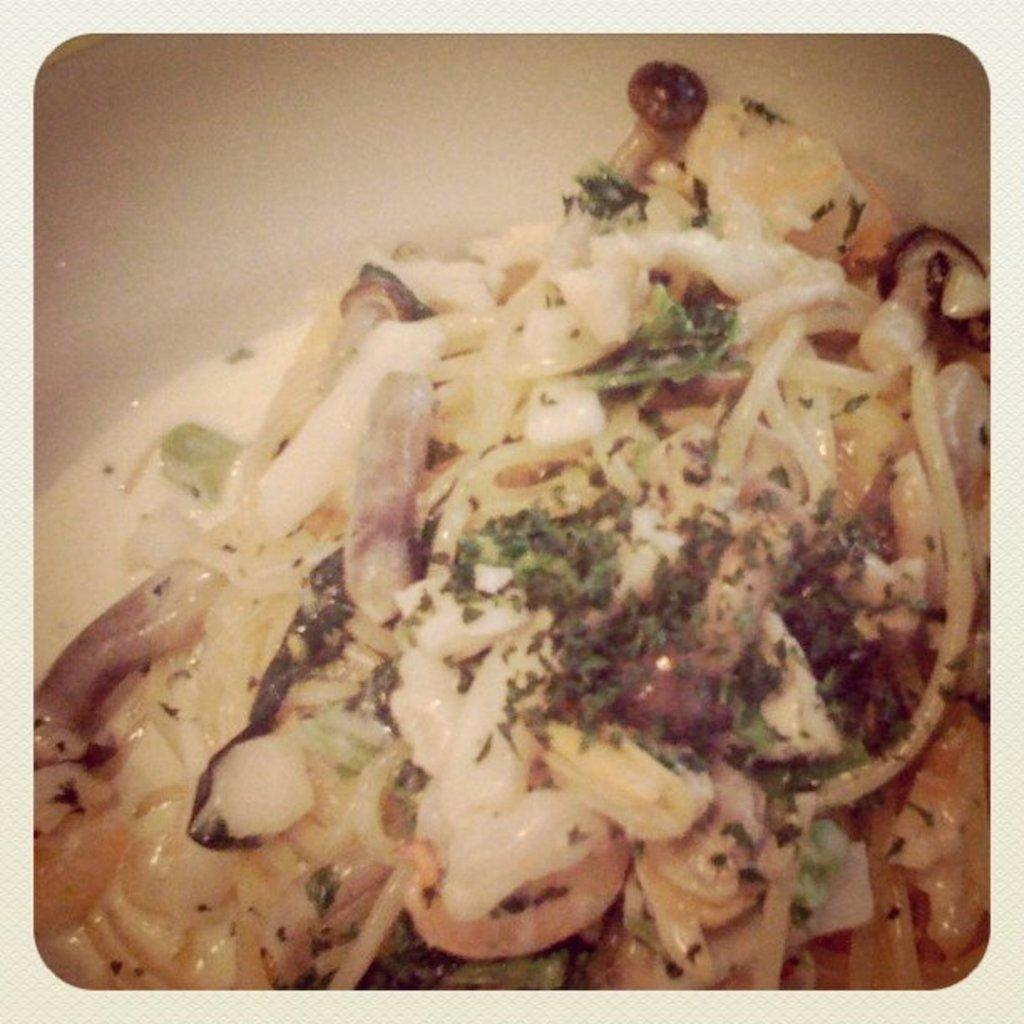What type of food is visible in the image? There is spaghetti in the image. What is sprinkled on top of the spaghetti? Coriander is sprinkled on top of the spaghetti. What is the cause of the argument between the light and care in the image? There is no argument, light, or care present in the image; it only features spaghetti with coriander on top. 